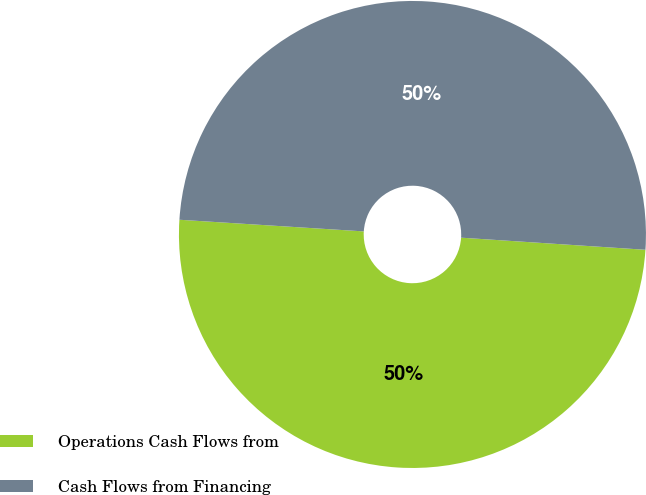Convert chart to OTSL. <chart><loc_0><loc_0><loc_500><loc_500><pie_chart><fcel>Operations Cash Flows from<fcel>Cash Flows from Financing<nl><fcel>49.96%<fcel>50.04%<nl></chart> 